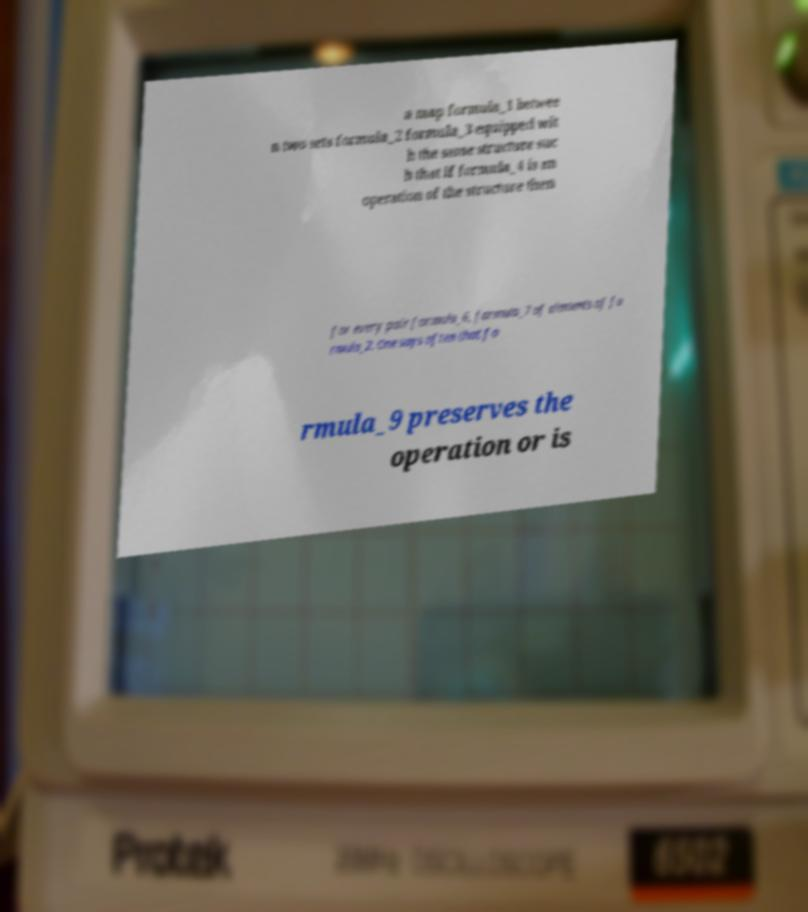For documentation purposes, I need the text within this image transcribed. Could you provide that? a map formula_1 betwee n two sets formula_2 formula_3 equipped wit h the same structure suc h that if formula_4 is an operation of the structure then for every pair formula_6, formula_7 of elements of fo rmula_2. One says often that fo rmula_9 preserves the operation or is 